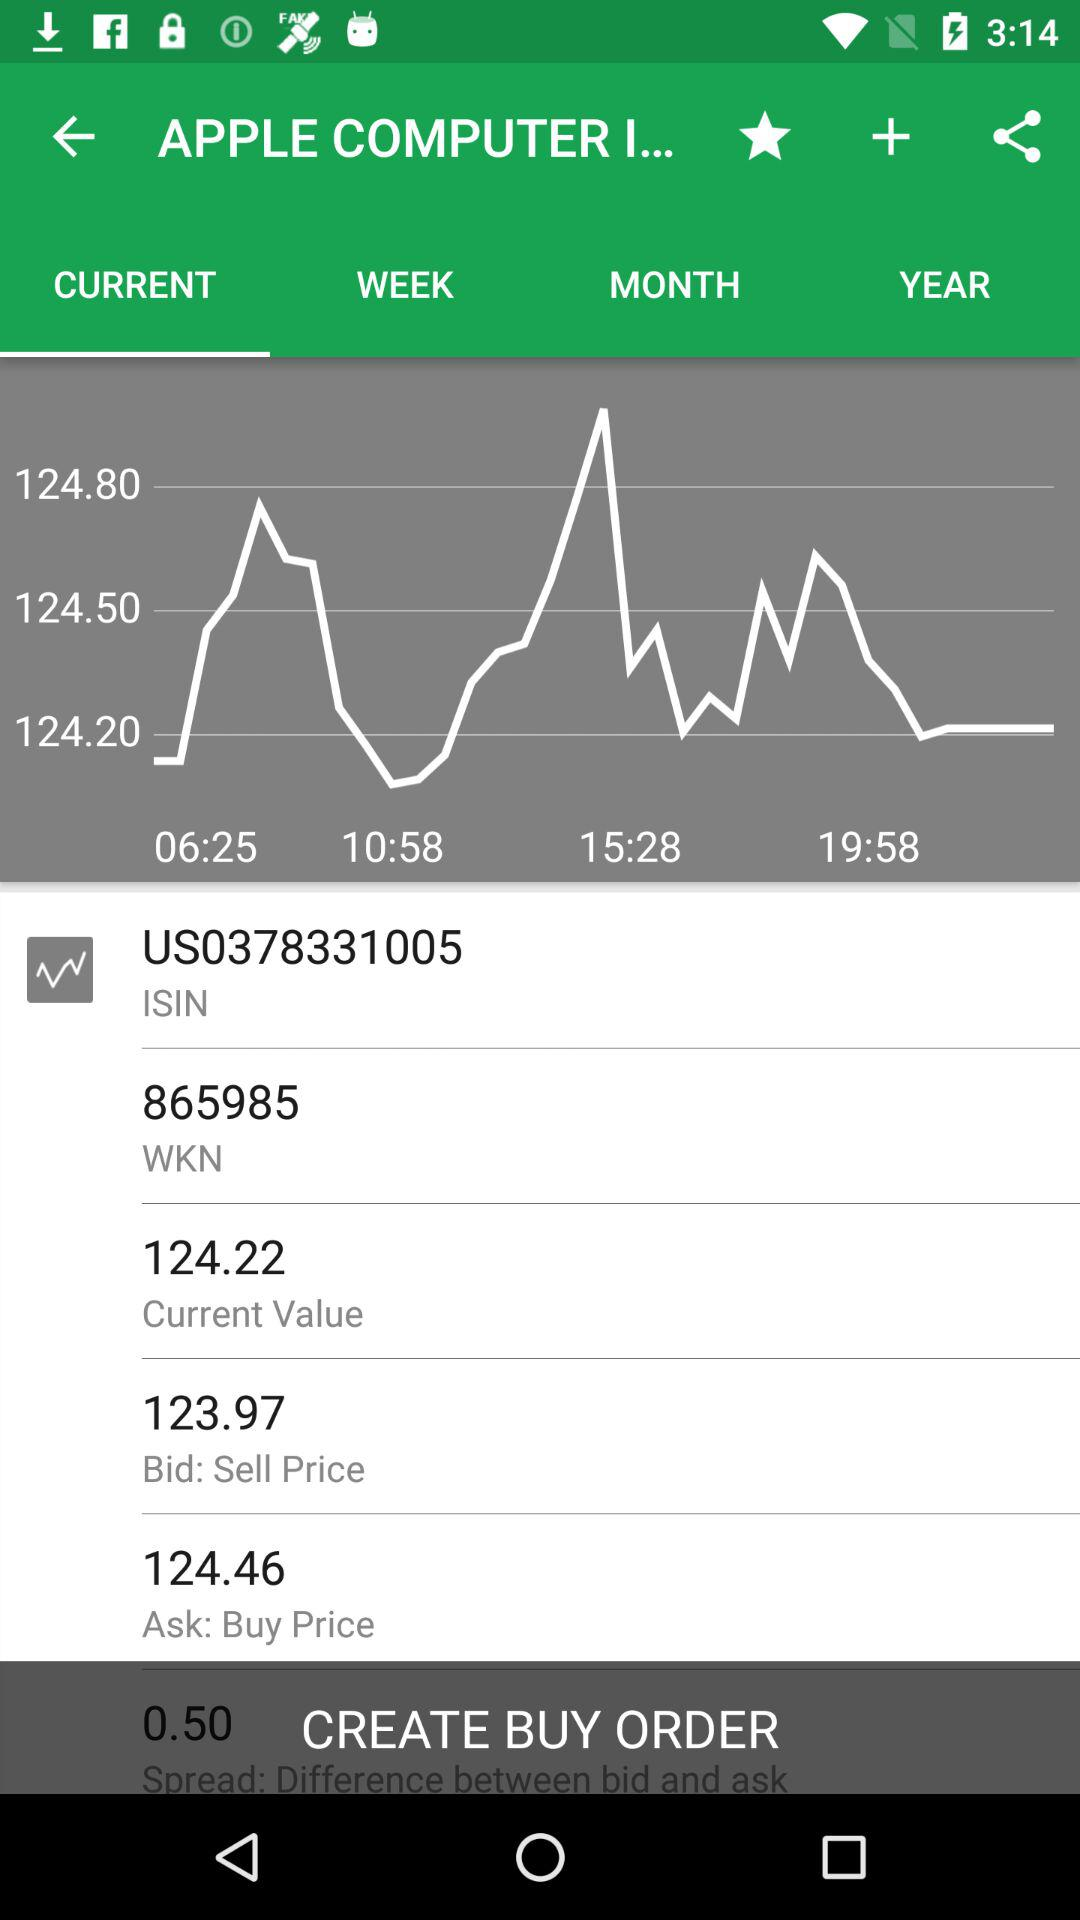What is the ISIN number? The ISIN number is US0378331005. 